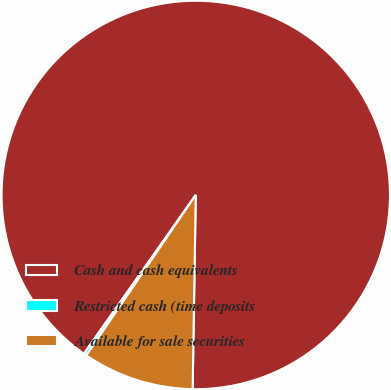<chart> <loc_0><loc_0><loc_500><loc_500><pie_chart><fcel>Cash and cash equivalents<fcel>Restricted cash (time deposits<fcel>Available for sale securities<nl><fcel>90.49%<fcel>0.24%<fcel>9.27%<nl></chart> 